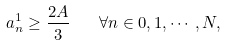<formula> <loc_0><loc_0><loc_500><loc_500>a _ { n } ^ { 1 } \geq \frac { 2 A } { 3 } \quad \forall n \in 0 , 1 , \cdots , N ,</formula> 